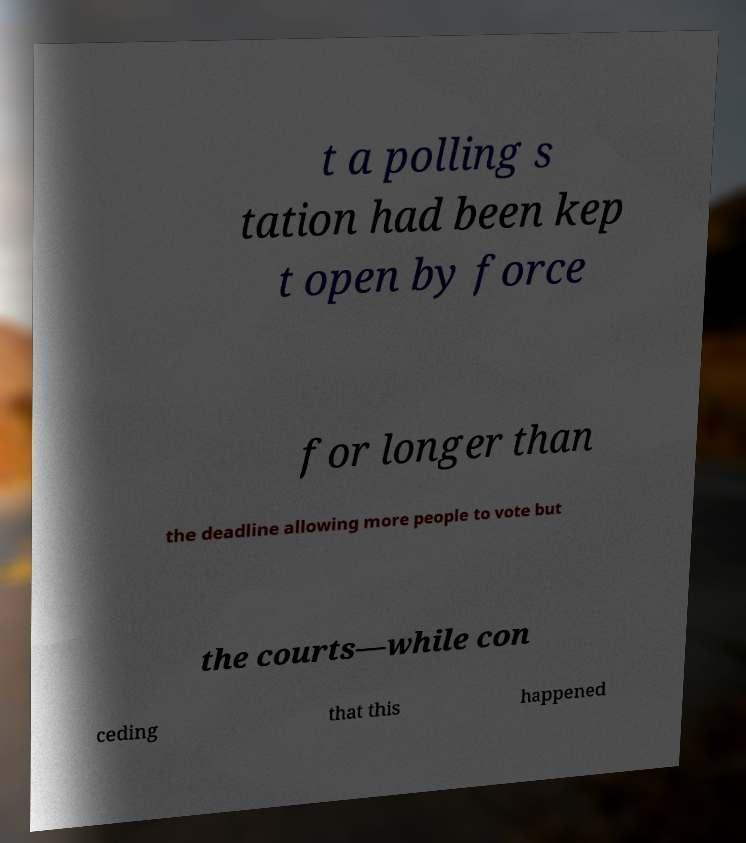What messages or text are displayed in this image? I need them in a readable, typed format. t a polling s tation had been kep t open by force for longer than the deadline allowing more people to vote but the courts—while con ceding that this happened 